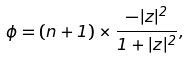<formula> <loc_0><loc_0><loc_500><loc_500>\phi = ( n + 1 ) \times \frac { - | z | ^ { 2 } } { 1 + | z | ^ { 2 } } ,</formula> 